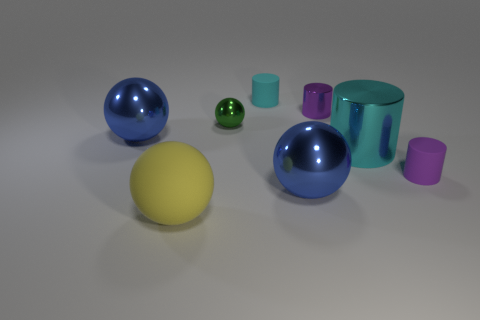There is a purple shiny object; does it have the same shape as the tiny matte object that is left of the large cyan cylinder?
Offer a terse response. Yes. How many small objects are yellow rubber spheres or red metallic blocks?
Offer a very short reply. 0. Is there a yellow cylinder that has the same size as the yellow rubber sphere?
Give a very brief answer. No. There is a rubber thing behind the blue shiny ball that is behind the big blue object that is in front of the small purple matte cylinder; what is its color?
Your answer should be compact. Cyan. Is the green sphere made of the same material as the cyan cylinder to the left of the cyan metal cylinder?
Provide a succinct answer. No. There is a green metallic object that is the same shape as the yellow thing; what is its size?
Provide a short and direct response. Small. Are there an equal number of metal objects left of the tiny green metal thing and tiny matte things to the right of the small purple shiny object?
Your response must be concise. Yes. What number of other things are the same material as the large yellow sphere?
Keep it short and to the point. 2. Are there an equal number of small green balls that are right of the big cyan thing and large brown matte objects?
Your answer should be compact. Yes. There is a cyan matte object; is it the same size as the matte thing in front of the purple rubber cylinder?
Provide a short and direct response. No. 